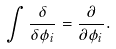Convert formula to latex. <formula><loc_0><loc_0><loc_500><loc_500>\int { \frac { \delta } { \delta \phi _ { i } } } = { \frac { \partial } { \partial \phi _ { i } } } .</formula> 